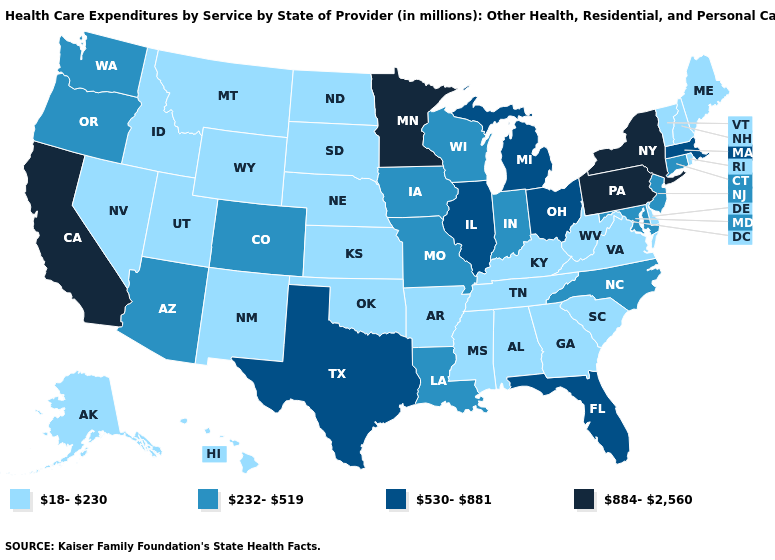Which states hav the highest value in the West?
Keep it brief. California. Among the states that border Idaho , does Utah have the highest value?
Answer briefly. No. What is the value of Missouri?
Quick response, please. 232-519. Which states have the highest value in the USA?
Concise answer only. California, Minnesota, New York, Pennsylvania. Among the states that border Wisconsin , does Illinois have the highest value?
Answer briefly. No. Is the legend a continuous bar?
Answer briefly. No. Name the states that have a value in the range 884-2,560?
Quick response, please. California, Minnesota, New York, Pennsylvania. Which states hav the highest value in the South?
Quick response, please. Florida, Texas. Name the states that have a value in the range 530-881?
Write a very short answer. Florida, Illinois, Massachusetts, Michigan, Ohio, Texas. What is the highest value in the USA?
Answer briefly. 884-2,560. What is the value of Missouri?
Quick response, please. 232-519. Does Pennsylvania have the lowest value in the USA?
Short answer required. No. What is the value of Georgia?
Be succinct. 18-230. What is the highest value in the USA?
Concise answer only. 884-2,560. What is the value of Maine?
Keep it brief. 18-230. 